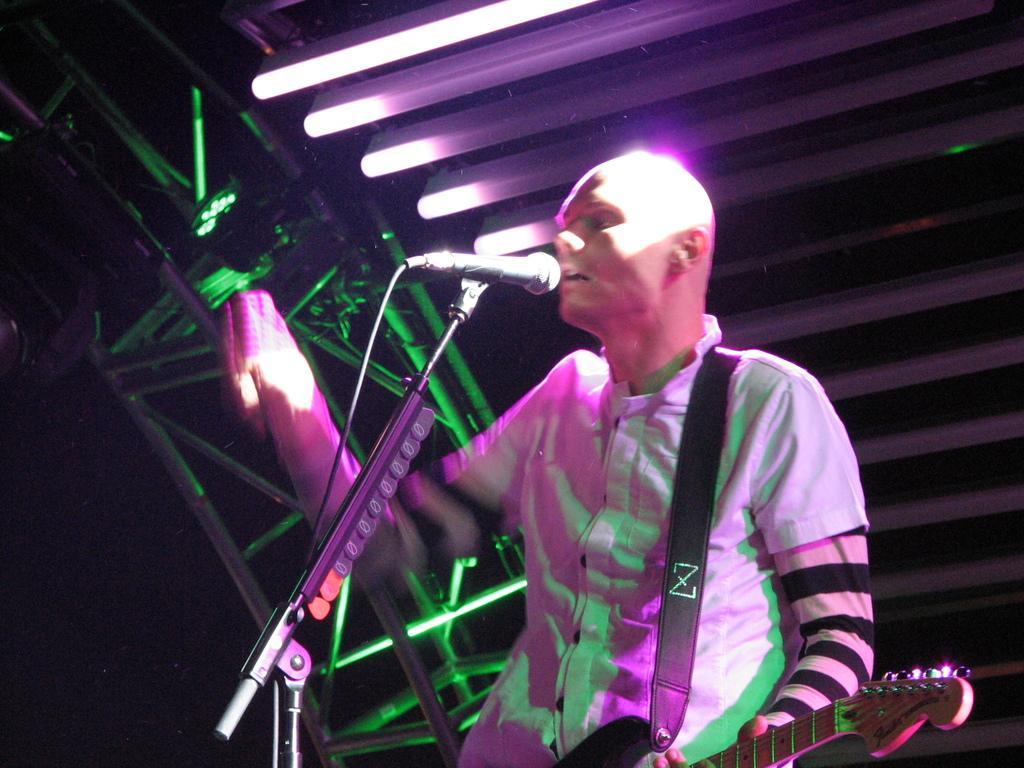Could you give a brief overview of what you see in this image? In this image i can see a person standing and holding a guitar in his hands. I can see a microphone in front of him. In the background i can see lights and metal rods. 